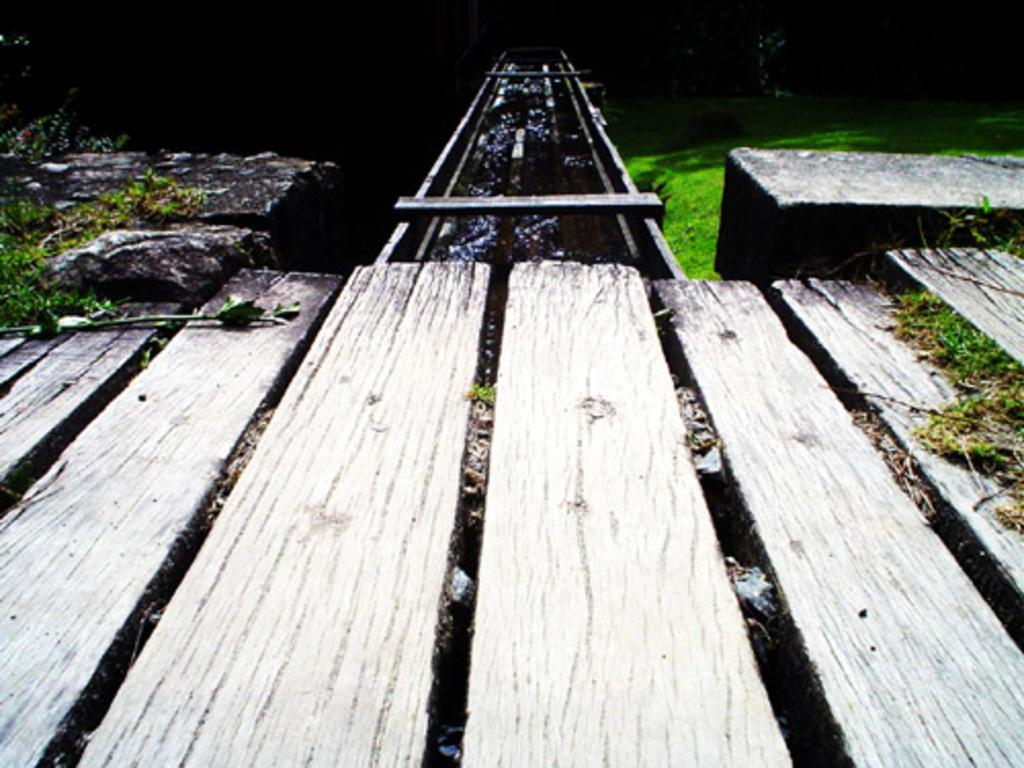What type of surface is present in the image? There is a wooden platform in the image. What other natural elements can be seen in the image? There are stones and grass in the image. Can you describe the unspecified object in the image? Unfortunately, the facts provided do not give any details about the unspecified object. How many rings are visible on the kitten in the image? There is no kitten present in the image, and therefore no rings can be observed. 